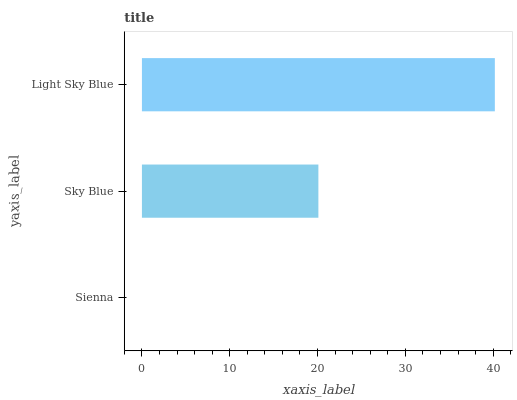Is Sienna the minimum?
Answer yes or no. Yes. Is Light Sky Blue the maximum?
Answer yes or no. Yes. Is Sky Blue the minimum?
Answer yes or no. No. Is Sky Blue the maximum?
Answer yes or no. No. Is Sky Blue greater than Sienna?
Answer yes or no. Yes. Is Sienna less than Sky Blue?
Answer yes or no. Yes. Is Sienna greater than Sky Blue?
Answer yes or no. No. Is Sky Blue less than Sienna?
Answer yes or no. No. Is Sky Blue the high median?
Answer yes or no. Yes. Is Sky Blue the low median?
Answer yes or no. Yes. Is Light Sky Blue the high median?
Answer yes or no. No. Is Sienna the low median?
Answer yes or no. No. 